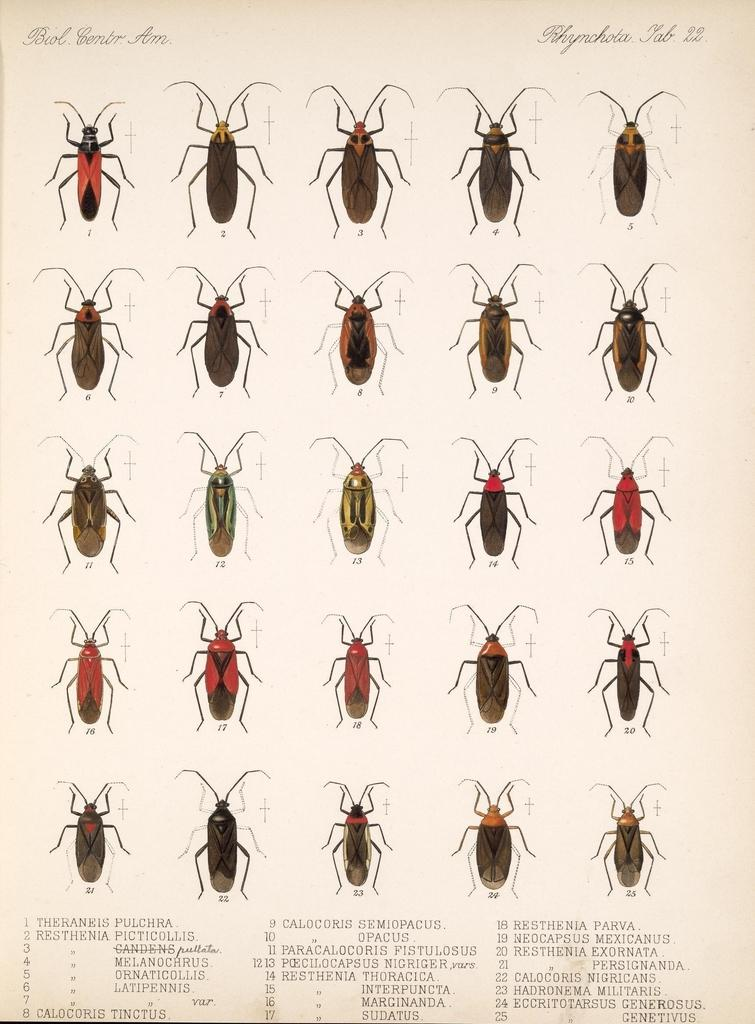What type of creatures are shown in the image? There are types of cockroaches depicted in the image. What else can be found on the page in the image? There is text on the page in the image. What is the aftermath of the nerve group in the image? There is no mention of a nerve group or any aftermath in the image; it only depicts cockroaches and text on a page. 